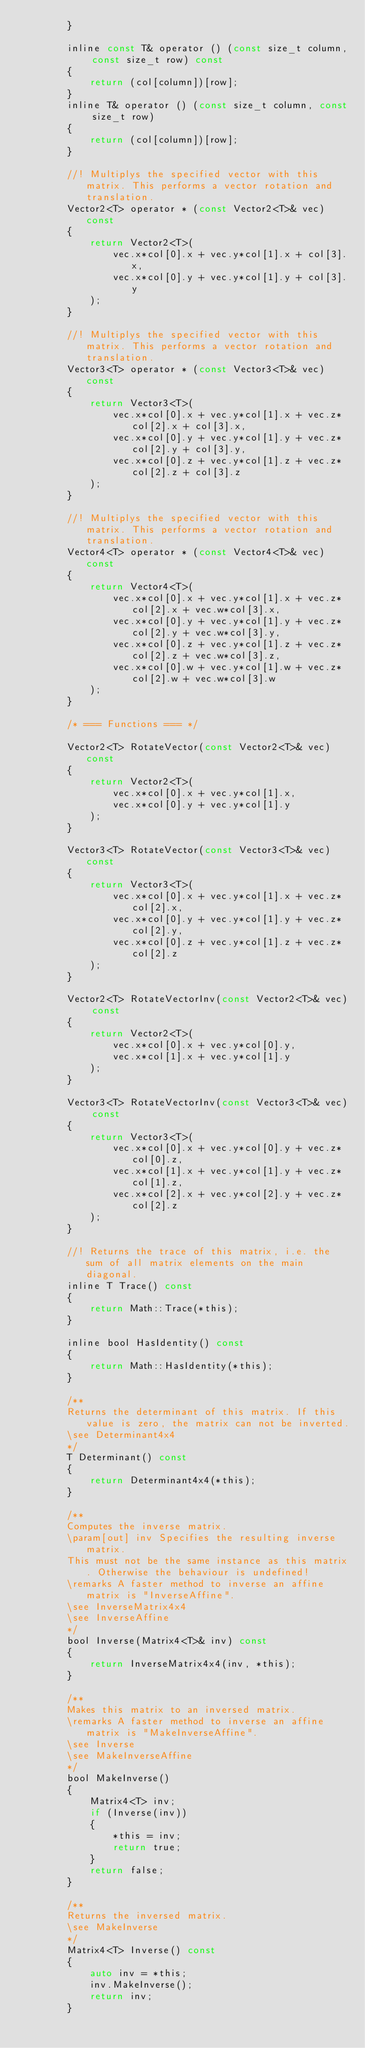<code> <loc_0><loc_0><loc_500><loc_500><_C_>        }

        inline const T& operator () (const size_t column, const size_t row) const
        {
            return (col[column])[row];
        }
        inline T& operator () (const size_t column, const size_t row)
        {
            return (col[column])[row];
        }

        //! Multiplys the specified vector with this matrix. This performs a vector rotation and translation.
        Vector2<T> operator * (const Vector2<T>& vec) const
        {
            return Vector2<T>(
                vec.x*col[0].x + vec.y*col[1].x + col[3].x,
                vec.x*col[0].y + vec.y*col[1].y + col[3].y
            );
        }

        //! Multiplys the specified vector with this matrix. This performs a vector rotation and translation.
        Vector3<T> operator * (const Vector3<T>& vec) const
        {
            return Vector3<T>(
                vec.x*col[0].x + vec.y*col[1].x + vec.z*col[2].x + col[3].x,
                vec.x*col[0].y + vec.y*col[1].y + vec.z*col[2].y + col[3].y,
                vec.x*col[0].z + vec.y*col[1].z + vec.z*col[2].z + col[3].z
            );
        }

        //! Multiplys the specified vector with this matrix. This performs a vector rotation and translation.
        Vector4<T> operator * (const Vector4<T>& vec) const
        {
            return Vector4<T>(
                vec.x*col[0].x + vec.y*col[1].x + vec.z*col[2].x + vec.w*col[3].x,
                vec.x*col[0].y + vec.y*col[1].y + vec.z*col[2].y + vec.w*col[3].y,
                vec.x*col[0].z + vec.y*col[1].z + vec.z*col[2].z + vec.w*col[3].z,
                vec.x*col[0].w + vec.y*col[1].w + vec.z*col[2].w + vec.w*col[3].w
            );
        }

        /* === Functions === */

        Vector2<T> RotateVector(const Vector2<T>& vec) const
        {
            return Vector2<T>(
                vec.x*col[0].x + vec.y*col[1].x,
                vec.x*col[0].y + vec.y*col[1].y
            );
        }

        Vector3<T> RotateVector(const Vector3<T>& vec) const
        {
            return Vector3<T>(
                vec.x*col[0].x + vec.y*col[1].x + vec.z*col[2].x,
                vec.x*col[0].y + vec.y*col[1].y + vec.z*col[2].y,
                vec.x*col[0].z + vec.y*col[1].z + vec.z*col[2].z
            );
        }

        Vector2<T> RotateVectorInv(const Vector2<T>& vec) const
        {
            return Vector2<T>(
                vec.x*col[0].x + vec.y*col[0].y,
                vec.x*col[1].x + vec.y*col[1].y
            );
        }

        Vector3<T> RotateVectorInv(const Vector3<T>& vec) const
        {
            return Vector3<T>(
                vec.x*col[0].x + vec.y*col[0].y + vec.z*col[0].z,
                vec.x*col[1].x + vec.y*col[1].y + vec.z*col[1].z,
                vec.x*col[2].x + vec.y*col[2].y + vec.z*col[2].z
            );
        }

        //! Returns the trace of this matrix, i.e. the sum of all matrix elements on the main diagonal.
        inline T Trace() const
        {
            return Math::Trace(*this);
        }

        inline bool HasIdentity() const
        {
            return Math::HasIdentity(*this);
        }

        /**
        Returns the determinant of this matrix. If this value is zero, the matrix can not be inverted.
        \see Determinant4x4
        */
        T Determinant() const
        {
            return Determinant4x4(*this);
        }

        /**
        Computes the inverse matrix.
        \param[out] inv Specifies the resulting inverse matrix.
        This must not be the same instance as this matrix. Otherwise the behaviour is undefined!
        \remarks A faster method to inverse an affine matrix is "InverseAffine".
        \see InverseMatrix4x4
        \see InverseAffine
        */
        bool Inverse(Matrix4<T>& inv) const
        {
            return InverseMatrix4x4(inv, *this);
        }

        /**
        Makes this matrix to an inversed matrix.
        \remarks A faster method to inverse an affine matrix is "MakeInverseAffine".
        \see Inverse
        \see MakeInverseAffine
        */
        bool MakeInverse()
        {
            Matrix4<T> inv;
            if (Inverse(inv))
            {
                *this = inv;
                return true;
            }
            return false;
        }

        /**
        Returns the inversed matrix.
        \see MakeInverse
        */
        Matrix4<T> Inverse() const
        {
            auto inv = *this;
            inv.MakeInverse();
            return inv;
        }
</code> 